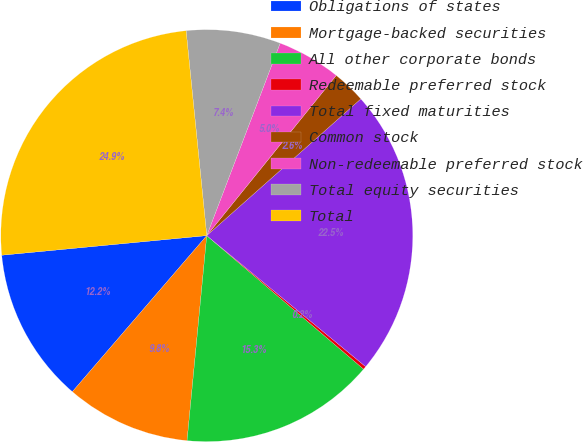Convert chart to OTSL. <chart><loc_0><loc_0><loc_500><loc_500><pie_chart><fcel>Obligations of states<fcel>Mortgage-backed securities<fcel>All other corporate bonds<fcel>Redeemable preferred stock<fcel>Total fixed maturities<fcel>Common stock<fcel>Non-redeemable preferred stock<fcel>Total equity securities<fcel>Total<nl><fcel>12.17%<fcel>9.79%<fcel>15.3%<fcel>0.25%<fcel>22.53%<fcel>2.63%<fcel>5.02%<fcel>7.4%<fcel>24.92%<nl></chart> 